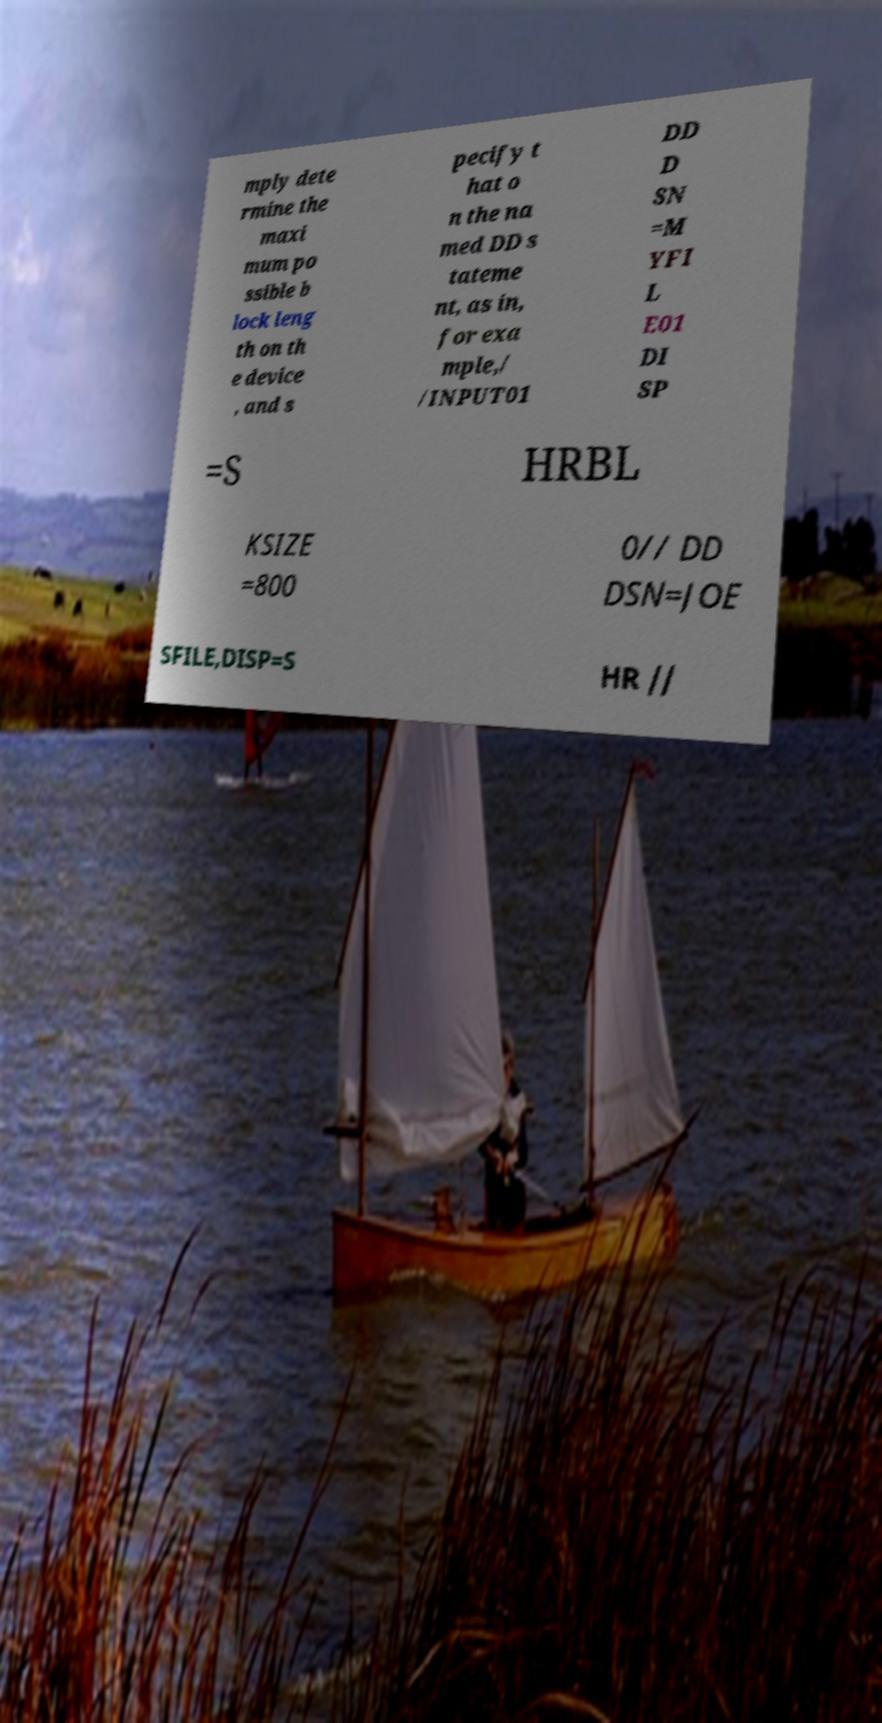Please read and relay the text visible in this image. What does it say? mply dete rmine the maxi mum po ssible b lock leng th on th e device , and s pecify t hat o n the na med DD s tateme nt, as in, for exa mple,/ /INPUT01 DD D SN =M YFI L E01 DI SP =S HRBL KSIZE =800 0// DD DSN=JOE SFILE,DISP=S HR // 